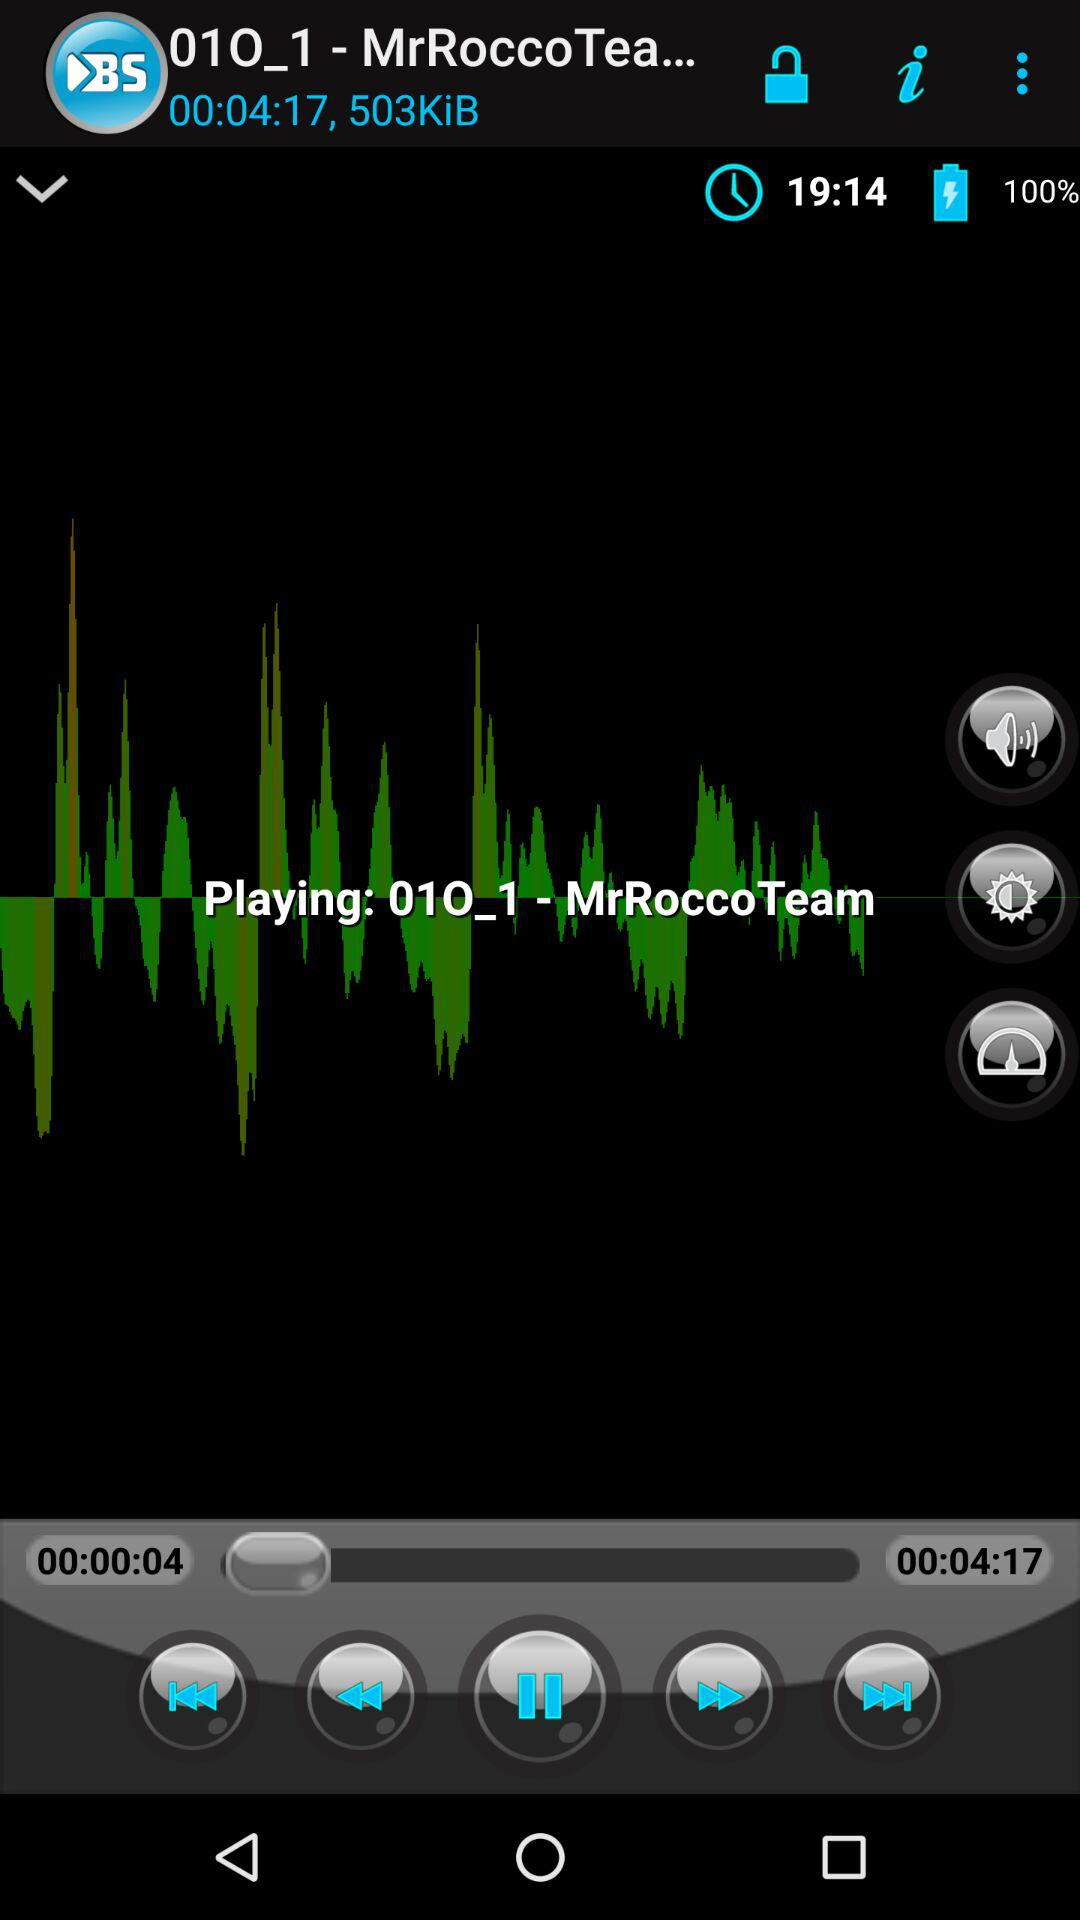What is the name of the song? The name of the song is "01O_1". 